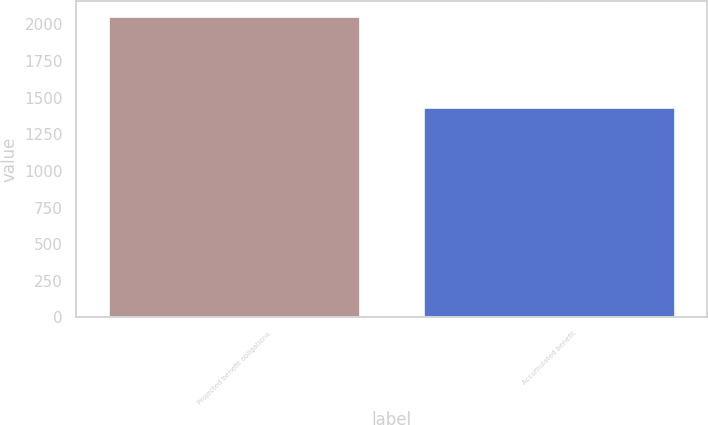<chart> <loc_0><loc_0><loc_500><loc_500><bar_chart><fcel>Projected benefit obligations<fcel>Accumulated benefit<nl><fcel>2055<fcel>1435<nl></chart> 